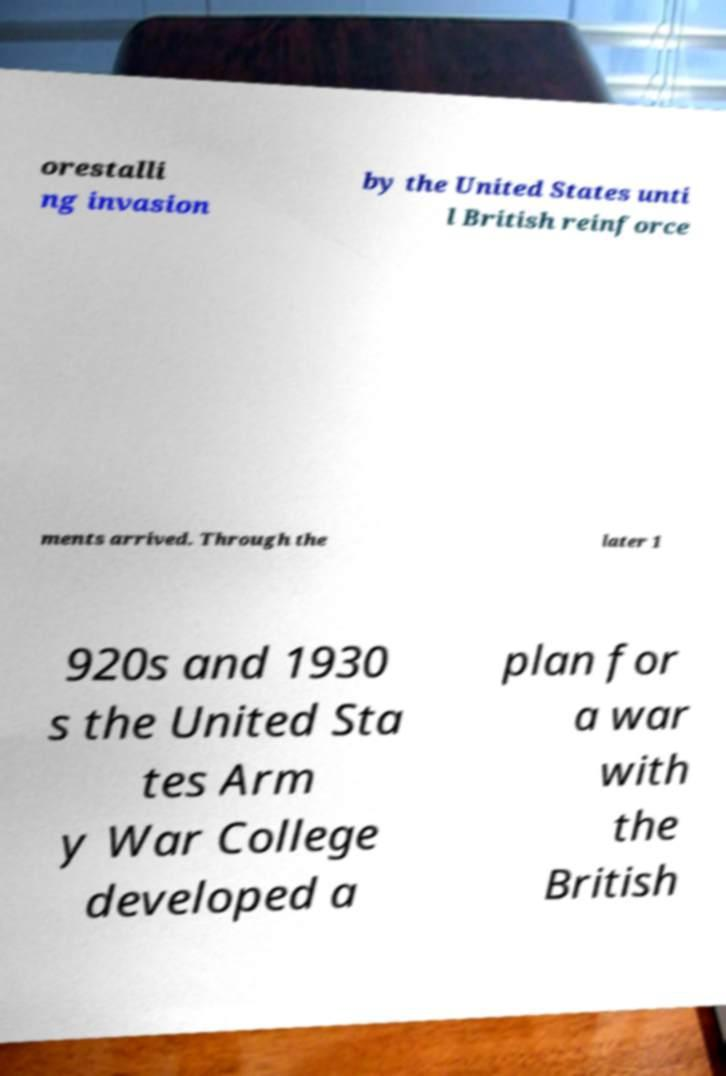What messages or text are displayed in this image? I need them in a readable, typed format. orestalli ng invasion by the United States unti l British reinforce ments arrived. Through the later 1 920s and 1930 s the United Sta tes Arm y War College developed a plan for a war with the British 